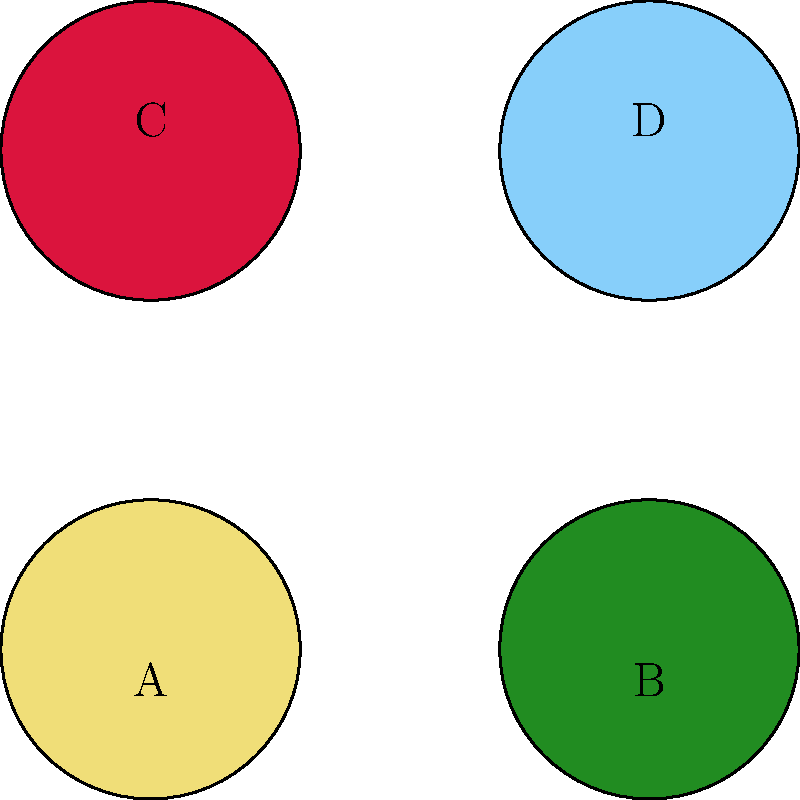Which color swatch best represents the emotional tone of the beach training scenes in The Karate Kid, and how does it contribute to the film's overall visual narrative? To answer this question, we need to analyze the color palette used in The Karate Kid, particularly during the beach training scenes, and understand how colors contribute to the film's emotional storytelling:

1. Pale yellow (A): This color represents warmth and optimism but doesn't strongly align with the beach training scenes.

2. Dark green (B): While green can symbolize growth, it's not prominent in the beach scenes.

3. Crimson (C): This intense red is more associated with conflict or danger, which doesn't fit the training scenes.

4. Light blue (D): This color best represents the beach training scenes for several reasons:

   a) It reflects the color of the sky and ocean, which are prominent in these scenes.
   b) Light blue conveys a sense of openness, possibility, and tranquility.
   c) It symbolizes the beginning of Daniel's journey and his spiritual growth.
   d) The cool tones contrast with the warm colors used in other parts of the film, highlighting the transformative nature of these scenes.

5. The use of light blue in these scenes contributes to the overall visual narrative by:
   
   a) Creating a calm, meditative atmosphere that underscores the importance of mental focus in martial arts.
   b) Symbolizing the cleansing and renewal Daniel experiences through his training.
   c) Contrasting with the darker, more intense colors used in conflict scenes, emphasizing the duality of peace and struggle in Daniel's journey.

Therefore, the light blue swatch (D) best represents the emotional tone of the beach training scenes and significantly contributes to the film's visual storytelling.
Answer: Light blue (D) 